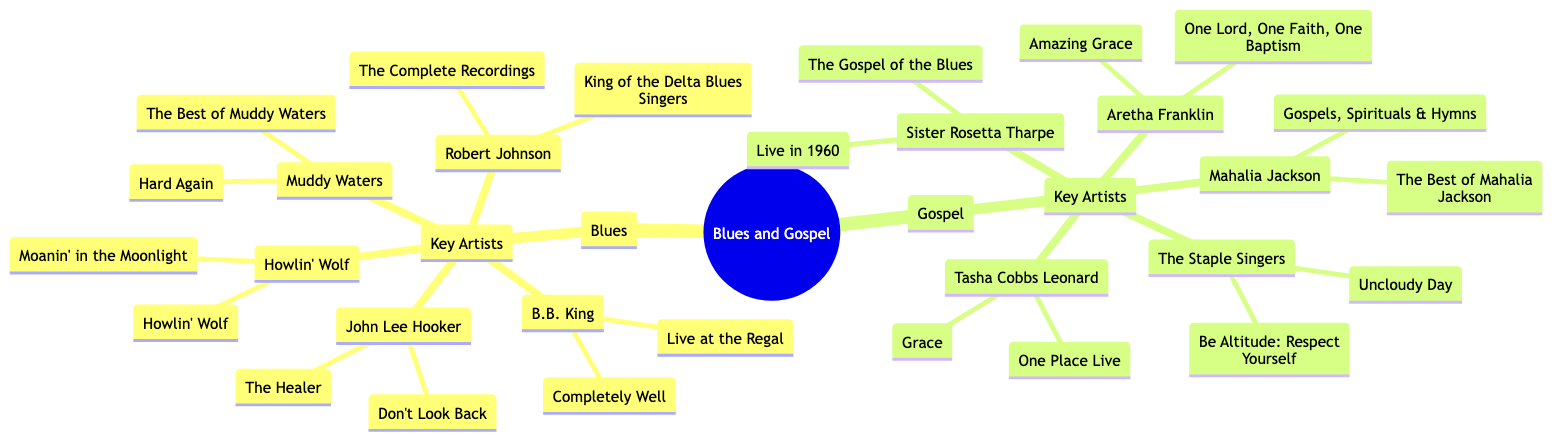What are the key artists in the Blues genre? The key artists can be found under the Blues category in the diagram. They include B.B. King, Muddy Waters, John Lee Hooker, Howlin' Wolf, and Robert Johnson.
Answer: B.B. King, Muddy Waters, John Lee Hooker, Howlin' Wolf, Robert Johnson How many key albums are listed for Aretha Franklin? By checking the Gospel category and looking specifically at Aretha Franklin, we see there are two albums listed: Amazing Grace and One Lord, One Faith, One Baptism.
Answer: 2 What is the first album listed for John Lee Hooker? By looking under the Blues category and finding John Lee Hooker, we note that The Healer is the first album mentioned in his section.
Answer: The Healer Which artist is associated with the album "Gospels, Spirituals & Hymns"? To find the artist for the album "Gospels, Spirituals & Hymns," we look in the Gospel section and identify Mahalia Jackson as the artist linked to that album.
Answer: Mahalia Jackson How many key artists are listed under the Gospel genre? Checking the Gospel section, we see five key artists listed: Mahalia Jackson, Sister Rosetta Tharpe, The Staple Singers, Aretha Franklin, and Tasha Cobbs Leonard. Therefore, there are five key artists in total.
Answer: 5 What is the relationship between Robert Johnson and his key albums? Robert Johnson is in the Blues category, and the albums associated with him include King of the Delta Blues Singers and The Complete Recordings. This shows that Robert Johnson is linked to those specific albums.
Answer: King of the Delta Blues Singers, The Complete Recordings Which artist has the album "Live in 1960"? We look at the Gospel section and find that Sister Rosetta Tharpe is associated with the album "Live in 1960."
Answer: Sister Rosetta Tharpe What are two key albums associated with Muddy Waters? Under the Blues category for Muddy Waters, the two key albums listed are Hard Again and The Best of Muddy Waters.
Answer: Hard Again, The Best of Muddy Waters Which genre has more key artists, Blues or Gospel? Counting the key artists, Blues has five (B.B. King, Muddy Waters, John Lee Hooker, Howlin' Wolf, Robert Johnson) while Gospel also has five (Mahalia Jackson, Sister Rosetta Tharpe, The Staple Singers, Aretha Franklin, Tasha Cobbs Leonard). Hence, they have the same number of key artists.
Answer: Same number 